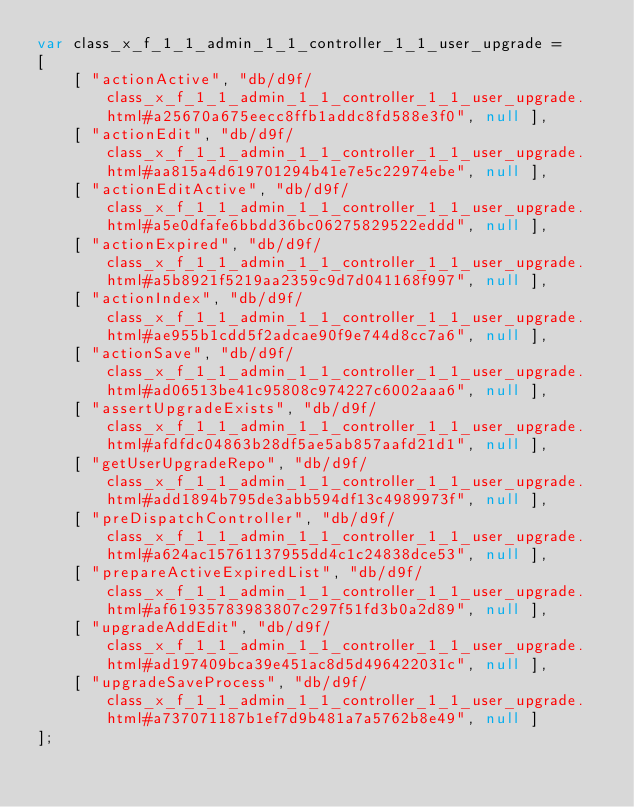Convert code to text. <code><loc_0><loc_0><loc_500><loc_500><_JavaScript_>var class_x_f_1_1_admin_1_1_controller_1_1_user_upgrade =
[
    [ "actionActive", "db/d9f/class_x_f_1_1_admin_1_1_controller_1_1_user_upgrade.html#a25670a675eecc8ffb1addc8fd588e3f0", null ],
    [ "actionEdit", "db/d9f/class_x_f_1_1_admin_1_1_controller_1_1_user_upgrade.html#aa815a4d619701294b41e7e5c22974ebe", null ],
    [ "actionEditActive", "db/d9f/class_x_f_1_1_admin_1_1_controller_1_1_user_upgrade.html#a5e0dfafe6bbdd36bc06275829522eddd", null ],
    [ "actionExpired", "db/d9f/class_x_f_1_1_admin_1_1_controller_1_1_user_upgrade.html#a5b8921f5219aa2359c9d7d041168f997", null ],
    [ "actionIndex", "db/d9f/class_x_f_1_1_admin_1_1_controller_1_1_user_upgrade.html#ae955b1cdd5f2adcae90f9e744d8cc7a6", null ],
    [ "actionSave", "db/d9f/class_x_f_1_1_admin_1_1_controller_1_1_user_upgrade.html#ad06513be41c95808c974227c6002aaa6", null ],
    [ "assertUpgradeExists", "db/d9f/class_x_f_1_1_admin_1_1_controller_1_1_user_upgrade.html#afdfdc04863b28df5ae5ab857aafd21d1", null ],
    [ "getUserUpgradeRepo", "db/d9f/class_x_f_1_1_admin_1_1_controller_1_1_user_upgrade.html#add1894b795de3abb594df13c4989973f", null ],
    [ "preDispatchController", "db/d9f/class_x_f_1_1_admin_1_1_controller_1_1_user_upgrade.html#a624ac15761137955dd4c1c24838dce53", null ],
    [ "prepareActiveExpiredList", "db/d9f/class_x_f_1_1_admin_1_1_controller_1_1_user_upgrade.html#af61935783983807c297f51fd3b0a2d89", null ],
    [ "upgradeAddEdit", "db/d9f/class_x_f_1_1_admin_1_1_controller_1_1_user_upgrade.html#ad197409bca39e451ac8d5d496422031c", null ],
    [ "upgradeSaveProcess", "db/d9f/class_x_f_1_1_admin_1_1_controller_1_1_user_upgrade.html#a737071187b1ef7d9b481a7a5762b8e49", null ]
];</code> 